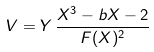Convert formula to latex. <formula><loc_0><loc_0><loc_500><loc_500>V = Y \, \frac { X ^ { 3 } - b X - 2 } { F ( X ) ^ { 2 } }</formula> 